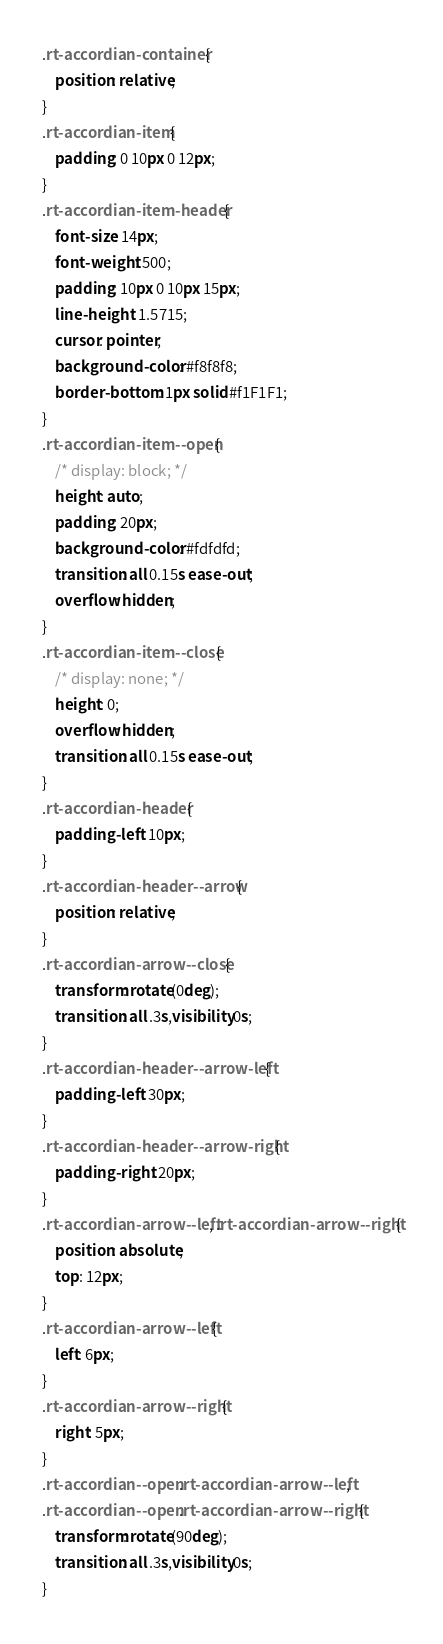<code> <loc_0><loc_0><loc_500><loc_500><_CSS_>.rt-accordian-container {
    position: relative;
}
.rt-accordian-item {
    padding: 0 10px 0 12px;
}
.rt-accordian-item-header {
    font-size: 14px;
    font-weight: 500;
    padding: 10px 0 10px 15px;
    line-height: 1.5715;
    cursor: pointer;
    background-color: #f8f8f8;
    border-bottom: 1px solid #f1F1F1;
}
.rt-accordian-item--open {
    /* display: block; */
    height: auto;
    padding: 20px;
    background-color: #fdfdfd;
    transition: all 0.15s ease-out;
    overflow: hidden;
}
.rt-accordian-item--close {
    /* display: none; */
    height: 0;
    overflow: hidden;
    transition: all 0.15s ease-out;
}
.rt-accordian-header {
    padding-left: 10px;
}
.rt-accordian-header--arrow {
    position: relative;
}
.rt-accordian-arrow--close {
    transform: rotate(0deg);
    transition: all .3s,visibility 0s;
}
.rt-accordian-header--arrow-left {
    padding-left: 30px;
}
.rt-accordian-header--arrow-right {
    padding-right: 20px;
}
.rt-accordian-arrow--left, .rt-accordian-arrow--right {
    position: absolute;
    top: 12px;
}
.rt-accordian-arrow--left {
    left: 6px;
}
.rt-accordian-arrow--right {
    right: 5px;
}
.rt-accordian--open .rt-accordian-arrow--left,  
.rt-accordian--open .rt-accordian-arrow--right {
    transform: rotate(90deg);
    transition: all .3s,visibility 0s;
}</code> 